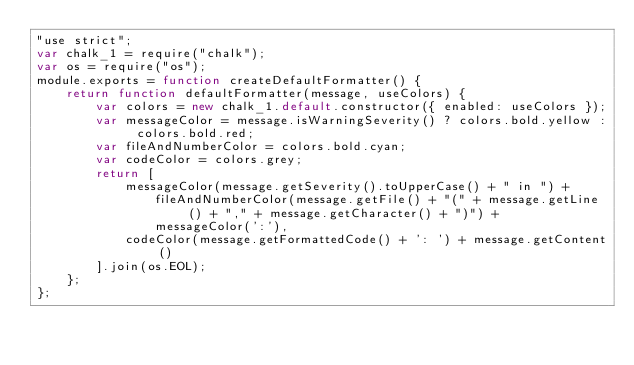Convert code to text. <code><loc_0><loc_0><loc_500><loc_500><_JavaScript_>"use strict";
var chalk_1 = require("chalk");
var os = require("os");
module.exports = function createDefaultFormatter() {
    return function defaultFormatter(message, useColors) {
        var colors = new chalk_1.default.constructor({ enabled: useColors });
        var messageColor = message.isWarningSeverity() ? colors.bold.yellow : colors.bold.red;
        var fileAndNumberColor = colors.bold.cyan;
        var codeColor = colors.grey;
        return [
            messageColor(message.getSeverity().toUpperCase() + " in ") +
                fileAndNumberColor(message.getFile() + "(" + message.getLine() + "," + message.getCharacter() + ")") +
                messageColor(':'),
            codeColor(message.getFormattedCode() + ': ') + message.getContent()
        ].join(os.EOL);
    };
};
</code> 